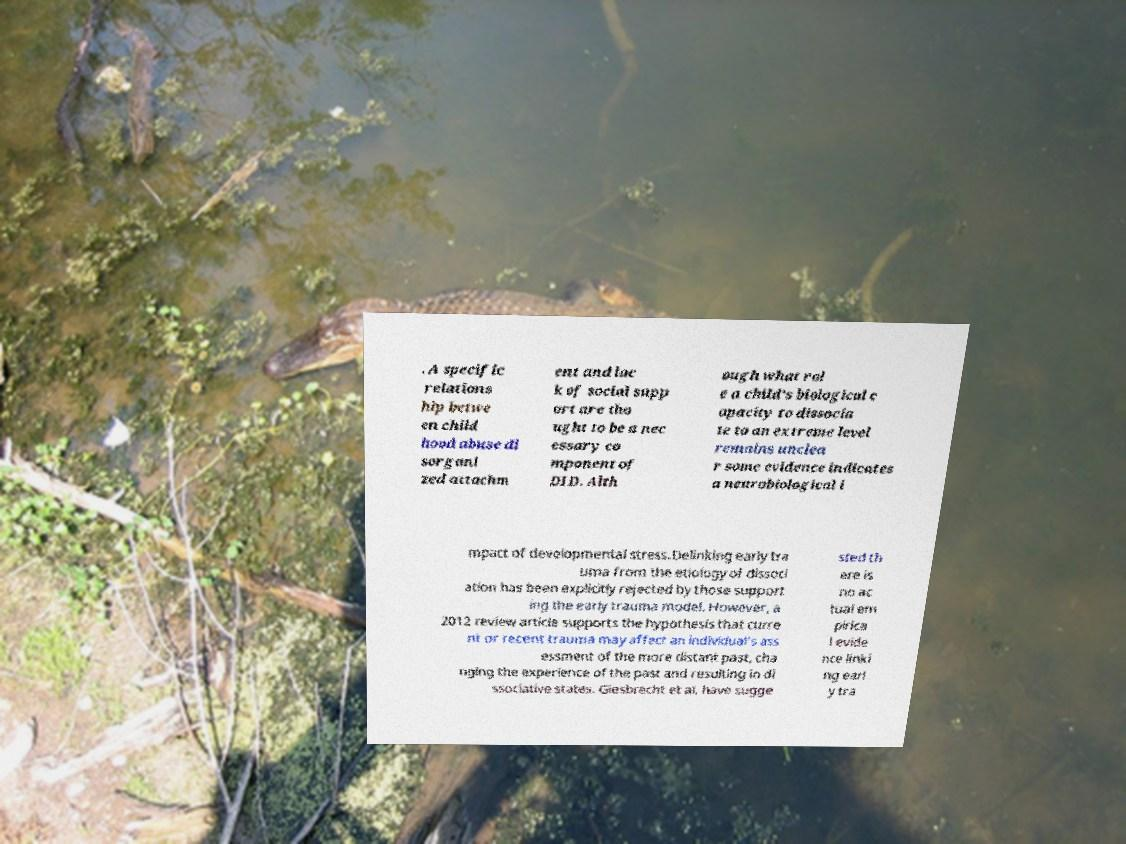Can you accurately transcribe the text from the provided image for me? . A specific relations hip betwe en child hood abuse di sorgani zed attachm ent and lac k of social supp ort are tho ught to be a nec essary co mponent of DID. Alth ough what rol e a child's biological c apacity to dissocia te to an extreme level remains unclea r some evidence indicates a neurobiological i mpact of developmental stress.Delinking early tra uma from the etiology of dissoci ation has been explicitly rejected by those support ing the early trauma model. However, a 2012 review article supports the hypothesis that curre nt or recent trauma may affect an individual's ass essment of the more distant past, cha nging the experience of the past and resulting in di ssociative states. Giesbrecht et al. have sugge sted th ere is no ac tual em pirica l evide nce linki ng earl y tra 